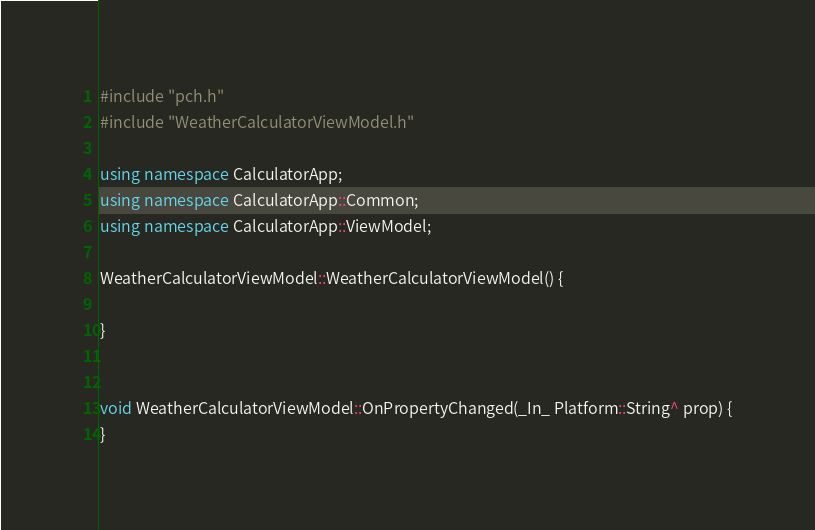<code> <loc_0><loc_0><loc_500><loc_500><_C++_>#include "pch.h"
#include "WeatherCalculatorViewModel.h"

using namespace CalculatorApp;
using namespace CalculatorApp::Common;
using namespace CalculatorApp::ViewModel;

WeatherCalculatorViewModel::WeatherCalculatorViewModel() {

}


void WeatherCalculatorViewModel::OnPropertyChanged(_In_ Platform::String^ prop) {
}


</code> 